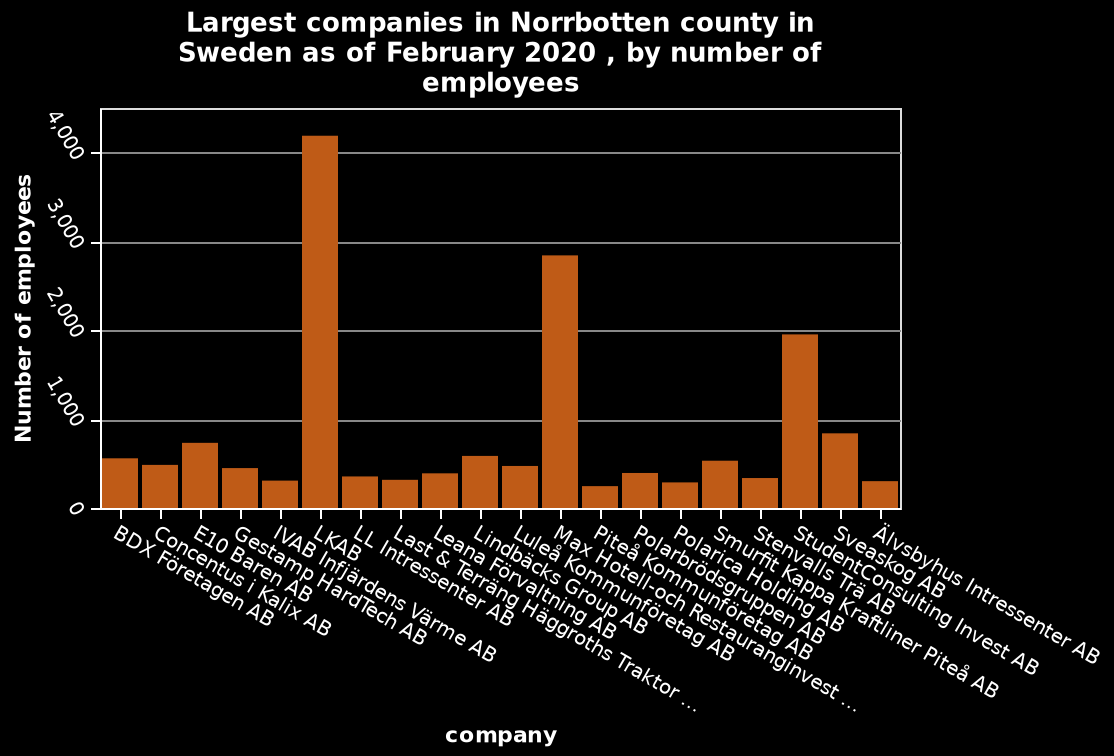<image>
please enumerates aspects of the construction of the chart This bar chart is titled Largest companies in Norrbotten county in Sweden as of February 2020 , by number of employees. On the y-axis, Number of employees is defined along a linear scale of range 0 to 4,000. There is a categorical scale starting at BDX Företagen AB and ending at Älvsbyhus Intressenter AB on the x-axis, labeled company. What is the average amount of employees among the 20 companies?  The average amount of employees is below 1000. What is defined on the y-axis of the bar chart?  The y-axis of the bar chart is defined by the "Number of employees" along a linear scale ranging from 0 to 4,000. please summary the statistics and relations of the chart LKAB has the largest amount of employees. The average amount of employees is below 1000.Out of 20 companies, only 2 have over 2000 employees. 